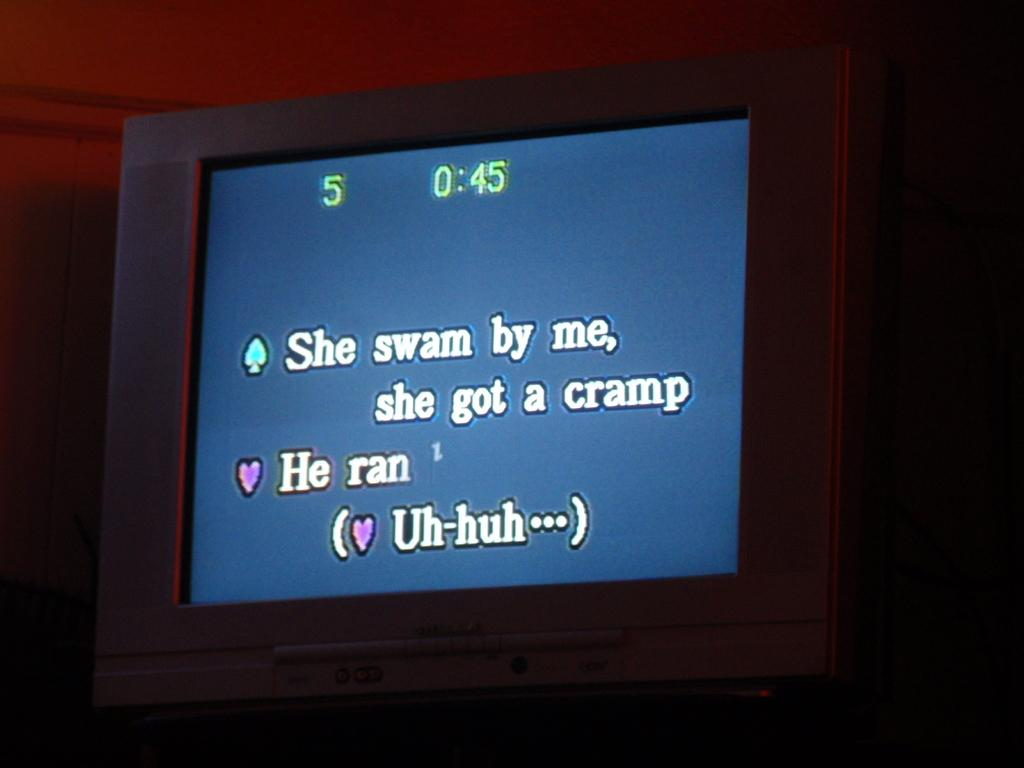Provide a one-sentence caption for the provided image. A blue screen shows the lyrics to a song for karoke. 